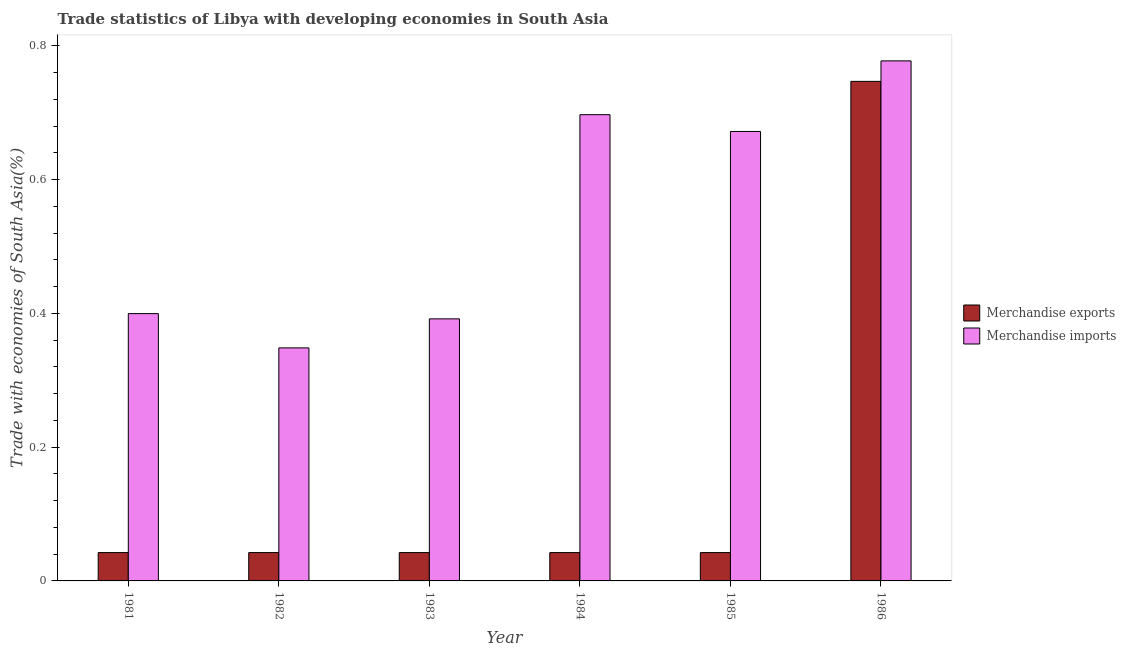How many different coloured bars are there?
Keep it short and to the point. 2. How many groups of bars are there?
Keep it short and to the point. 6. Are the number of bars per tick equal to the number of legend labels?
Your response must be concise. Yes. Are the number of bars on each tick of the X-axis equal?
Your answer should be compact. Yes. What is the label of the 6th group of bars from the left?
Offer a terse response. 1986. In how many cases, is the number of bars for a given year not equal to the number of legend labels?
Offer a very short reply. 0. What is the merchandise exports in 1985?
Make the answer very short. 0.04. Across all years, what is the maximum merchandise imports?
Keep it short and to the point. 0.78. Across all years, what is the minimum merchandise exports?
Your answer should be very brief. 0.04. In which year was the merchandise exports maximum?
Give a very brief answer. 1986. In which year was the merchandise exports minimum?
Your answer should be very brief. 1985. What is the total merchandise imports in the graph?
Your answer should be compact. 3.29. What is the difference between the merchandise exports in 1981 and that in 1986?
Offer a terse response. -0.7. What is the difference between the merchandise exports in 1986 and the merchandise imports in 1984?
Give a very brief answer. 0.7. What is the average merchandise exports per year?
Provide a succinct answer. 0.16. In how many years, is the merchandise imports greater than 0.24000000000000002 %?
Offer a terse response. 6. What is the ratio of the merchandise imports in 1984 to that in 1985?
Offer a terse response. 1.04. What is the difference between the highest and the second highest merchandise imports?
Your answer should be compact. 0.08. What is the difference between the highest and the lowest merchandise imports?
Offer a terse response. 0.43. How many years are there in the graph?
Offer a very short reply. 6. Does the graph contain grids?
Offer a very short reply. No. What is the title of the graph?
Your answer should be compact. Trade statistics of Libya with developing economies in South Asia. What is the label or title of the Y-axis?
Your answer should be very brief. Trade with economies of South Asia(%). What is the Trade with economies of South Asia(%) in Merchandise exports in 1981?
Provide a short and direct response. 0.04. What is the Trade with economies of South Asia(%) in Merchandise imports in 1981?
Provide a succinct answer. 0.4. What is the Trade with economies of South Asia(%) in Merchandise exports in 1982?
Offer a terse response. 0.04. What is the Trade with economies of South Asia(%) of Merchandise imports in 1982?
Give a very brief answer. 0.35. What is the Trade with economies of South Asia(%) in Merchandise exports in 1983?
Offer a terse response. 0.04. What is the Trade with economies of South Asia(%) in Merchandise imports in 1983?
Provide a succinct answer. 0.39. What is the Trade with economies of South Asia(%) in Merchandise exports in 1984?
Make the answer very short. 0.04. What is the Trade with economies of South Asia(%) in Merchandise imports in 1984?
Your answer should be compact. 0.7. What is the Trade with economies of South Asia(%) of Merchandise exports in 1985?
Give a very brief answer. 0.04. What is the Trade with economies of South Asia(%) of Merchandise imports in 1985?
Give a very brief answer. 0.67. What is the Trade with economies of South Asia(%) of Merchandise exports in 1986?
Provide a short and direct response. 0.75. What is the Trade with economies of South Asia(%) in Merchandise imports in 1986?
Your response must be concise. 0.78. Across all years, what is the maximum Trade with economies of South Asia(%) of Merchandise exports?
Provide a succinct answer. 0.75. Across all years, what is the maximum Trade with economies of South Asia(%) of Merchandise imports?
Your answer should be compact. 0.78. Across all years, what is the minimum Trade with economies of South Asia(%) in Merchandise exports?
Provide a succinct answer. 0.04. Across all years, what is the minimum Trade with economies of South Asia(%) in Merchandise imports?
Offer a very short reply. 0.35. What is the total Trade with economies of South Asia(%) in Merchandise exports in the graph?
Your answer should be compact. 0.96. What is the total Trade with economies of South Asia(%) in Merchandise imports in the graph?
Give a very brief answer. 3.29. What is the difference between the Trade with economies of South Asia(%) of Merchandise imports in 1981 and that in 1982?
Provide a short and direct response. 0.05. What is the difference between the Trade with economies of South Asia(%) in Merchandise exports in 1981 and that in 1983?
Offer a very short reply. -0. What is the difference between the Trade with economies of South Asia(%) in Merchandise imports in 1981 and that in 1983?
Provide a short and direct response. 0.01. What is the difference between the Trade with economies of South Asia(%) in Merchandise exports in 1981 and that in 1984?
Ensure brevity in your answer.  -0. What is the difference between the Trade with economies of South Asia(%) of Merchandise imports in 1981 and that in 1984?
Your answer should be compact. -0.3. What is the difference between the Trade with economies of South Asia(%) of Merchandise imports in 1981 and that in 1985?
Your answer should be very brief. -0.27. What is the difference between the Trade with economies of South Asia(%) in Merchandise exports in 1981 and that in 1986?
Your answer should be compact. -0.7. What is the difference between the Trade with economies of South Asia(%) of Merchandise imports in 1981 and that in 1986?
Your answer should be compact. -0.38. What is the difference between the Trade with economies of South Asia(%) of Merchandise imports in 1982 and that in 1983?
Ensure brevity in your answer.  -0.04. What is the difference between the Trade with economies of South Asia(%) in Merchandise exports in 1982 and that in 1984?
Your answer should be compact. -0. What is the difference between the Trade with economies of South Asia(%) in Merchandise imports in 1982 and that in 1984?
Make the answer very short. -0.35. What is the difference between the Trade with economies of South Asia(%) of Merchandise exports in 1982 and that in 1985?
Make the answer very short. 0. What is the difference between the Trade with economies of South Asia(%) of Merchandise imports in 1982 and that in 1985?
Provide a short and direct response. -0.32. What is the difference between the Trade with economies of South Asia(%) in Merchandise exports in 1982 and that in 1986?
Offer a very short reply. -0.7. What is the difference between the Trade with economies of South Asia(%) in Merchandise imports in 1982 and that in 1986?
Offer a very short reply. -0.43. What is the difference between the Trade with economies of South Asia(%) of Merchandise imports in 1983 and that in 1984?
Your response must be concise. -0.31. What is the difference between the Trade with economies of South Asia(%) in Merchandise imports in 1983 and that in 1985?
Keep it short and to the point. -0.28. What is the difference between the Trade with economies of South Asia(%) of Merchandise exports in 1983 and that in 1986?
Offer a very short reply. -0.7. What is the difference between the Trade with economies of South Asia(%) in Merchandise imports in 1983 and that in 1986?
Your response must be concise. -0.39. What is the difference between the Trade with economies of South Asia(%) of Merchandise imports in 1984 and that in 1985?
Give a very brief answer. 0.03. What is the difference between the Trade with economies of South Asia(%) of Merchandise exports in 1984 and that in 1986?
Offer a terse response. -0.7. What is the difference between the Trade with economies of South Asia(%) in Merchandise imports in 1984 and that in 1986?
Keep it short and to the point. -0.08. What is the difference between the Trade with economies of South Asia(%) in Merchandise exports in 1985 and that in 1986?
Make the answer very short. -0.7. What is the difference between the Trade with economies of South Asia(%) of Merchandise imports in 1985 and that in 1986?
Ensure brevity in your answer.  -0.11. What is the difference between the Trade with economies of South Asia(%) of Merchandise exports in 1981 and the Trade with economies of South Asia(%) of Merchandise imports in 1982?
Offer a terse response. -0.31. What is the difference between the Trade with economies of South Asia(%) of Merchandise exports in 1981 and the Trade with economies of South Asia(%) of Merchandise imports in 1983?
Provide a short and direct response. -0.35. What is the difference between the Trade with economies of South Asia(%) of Merchandise exports in 1981 and the Trade with economies of South Asia(%) of Merchandise imports in 1984?
Make the answer very short. -0.65. What is the difference between the Trade with economies of South Asia(%) of Merchandise exports in 1981 and the Trade with economies of South Asia(%) of Merchandise imports in 1985?
Make the answer very short. -0.63. What is the difference between the Trade with economies of South Asia(%) in Merchandise exports in 1981 and the Trade with economies of South Asia(%) in Merchandise imports in 1986?
Make the answer very short. -0.74. What is the difference between the Trade with economies of South Asia(%) in Merchandise exports in 1982 and the Trade with economies of South Asia(%) in Merchandise imports in 1983?
Provide a succinct answer. -0.35. What is the difference between the Trade with economies of South Asia(%) in Merchandise exports in 1982 and the Trade with economies of South Asia(%) in Merchandise imports in 1984?
Your response must be concise. -0.65. What is the difference between the Trade with economies of South Asia(%) in Merchandise exports in 1982 and the Trade with economies of South Asia(%) in Merchandise imports in 1985?
Provide a succinct answer. -0.63. What is the difference between the Trade with economies of South Asia(%) in Merchandise exports in 1982 and the Trade with economies of South Asia(%) in Merchandise imports in 1986?
Provide a succinct answer. -0.74. What is the difference between the Trade with economies of South Asia(%) of Merchandise exports in 1983 and the Trade with economies of South Asia(%) of Merchandise imports in 1984?
Keep it short and to the point. -0.65. What is the difference between the Trade with economies of South Asia(%) of Merchandise exports in 1983 and the Trade with economies of South Asia(%) of Merchandise imports in 1985?
Offer a very short reply. -0.63. What is the difference between the Trade with economies of South Asia(%) in Merchandise exports in 1983 and the Trade with economies of South Asia(%) in Merchandise imports in 1986?
Offer a terse response. -0.74. What is the difference between the Trade with economies of South Asia(%) of Merchandise exports in 1984 and the Trade with economies of South Asia(%) of Merchandise imports in 1985?
Offer a terse response. -0.63. What is the difference between the Trade with economies of South Asia(%) of Merchandise exports in 1984 and the Trade with economies of South Asia(%) of Merchandise imports in 1986?
Provide a short and direct response. -0.74. What is the difference between the Trade with economies of South Asia(%) in Merchandise exports in 1985 and the Trade with economies of South Asia(%) in Merchandise imports in 1986?
Your response must be concise. -0.74. What is the average Trade with economies of South Asia(%) in Merchandise exports per year?
Your response must be concise. 0.16. What is the average Trade with economies of South Asia(%) of Merchandise imports per year?
Your response must be concise. 0.55. In the year 1981, what is the difference between the Trade with economies of South Asia(%) in Merchandise exports and Trade with economies of South Asia(%) in Merchandise imports?
Your answer should be compact. -0.36. In the year 1982, what is the difference between the Trade with economies of South Asia(%) of Merchandise exports and Trade with economies of South Asia(%) of Merchandise imports?
Provide a succinct answer. -0.31. In the year 1983, what is the difference between the Trade with economies of South Asia(%) of Merchandise exports and Trade with economies of South Asia(%) of Merchandise imports?
Your response must be concise. -0.35. In the year 1984, what is the difference between the Trade with economies of South Asia(%) in Merchandise exports and Trade with economies of South Asia(%) in Merchandise imports?
Provide a short and direct response. -0.65. In the year 1985, what is the difference between the Trade with economies of South Asia(%) of Merchandise exports and Trade with economies of South Asia(%) of Merchandise imports?
Your answer should be very brief. -0.63. In the year 1986, what is the difference between the Trade with economies of South Asia(%) of Merchandise exports and Trade with economies of South Asia(%) of Merchandise imports?
Offer a terse response. -0.03. What is the ratio of the Trade with economies of South Asia(%) of Merchandise exports in 1981 to that in 1982?
Offer a terse response. 1. What is the ratio of the Trade with economies of South Asia(%) in Merchandise imports in 1981 to that in 1982?
Provide a succinct answer. 1.15. What is the ratio of the Trade with economies of South Asia(%) in Merchandise exports in 1981 to that in 1983?
Your response must be concise. 1. What is the ratio of the Trade with economies of South Asia(%) of Merchandise imports in 1981 to that in 1983?
Keep it short and to the point. 1.02. What is the ratio of the Trade with economies of South Asia(%) in Merchandise imports in 1981 to that in 1984?
Offer a very short reply. 0.57. What is the ratio of the Trade with economies of South Asia(%) of Merchandise exports in 1981 to that in 1985?
Keep it short and to the point. 1. What is the ratio of the Trade with economies of South Asia(%) of Merchandise imports in 1981 to that in 1985?
Keep it short and to the point. 0.59. What is the ratio of the Trade with economies of South Asia(%) of Merchandise exports in 1981 to that in 1986?
Provide a succinct answer. 0.06. What is the ratio of the Trade with economies of South Asia(%) in Merchandise imports in 1981 to that in 1986?
Your answer should be compact. 0.51. What is the ratio of the Trade with economies of South Asia(%) of Merchandise imports in 1982 to that in 1983?
Your answer should be very brief. 0.89. What is the ratio of the Trade with economies of South Asia(%) in Merchandise exports in 1982 to that in 1984?
Your answer should be compact. 1. What is the ratio of the Trade with economies of South Asia(%) of Merchandise imports in 1982 to that in 1984?
Keep it short and to the point. 0.5. What is the ratio of the Trade with economies of South Asia(%) of Merchandise imports in 1982 to that in 1985?
Provide a succinct answer. 0.52. What is the ratio of the Trade with economies of South Asia(%) in Merchandise exports in 1982 to that in 1986?
Ensure brevity in your answer.  0.06. What is the ratio of the Trade with economies of South Asia(%) of Merchandise imports in 1982 to that in 1986?
Keep it short and to the point. 0.45. What is the ratio of the Trade with economies of South Asia(%) of Merchandise exports in 1983 to that in 1984?
Provide a short and direct response. 1. What is the ratio of the Trade with economies of South Asia(%) of Merchandise imports in 1983 to that in 1984?
Your answer should be compact. 0.56. What is the ratio of the Trade with economies of South Asia(%) in Merchandise exports in 1983 to that in 1985?
Your answer should be compact. 1. What is the ratio of the Trade with economies of South Asia(%) in Merchandise imports in 1983 to that in 1985?
Your answer should be very brief. 0.58. What is the ratio of the Trade with economies of South Asia(%) of Merchandise exports in 1983 to that in 1986?
Ensure brevity in your answer.  0.06. What is the ratio of the Trade with economies of South Asia(%) in Merchandise imports in 1983 to that in 1986?
Your response must be concise. 0.5. What is the ratio of the Trade with economies of South Asia(%) in Merchandise exports in 1984 to that in 1985?
Offer a very short reply. 1. What is the ratio of the Trade with economies of South Asia(%) in Merchandise imports in 1984 to that in 1985?
Give a very brief answer. 1.04. What is the ratio of the Trade with economies of South Asia(%) of Merchandise exports in 1984 to that in 1986?
Give a very brief answer. 0.06. What is the ratio of the Trade with economies of South Asia(%) in Merchandise imports in 1984 to that in 1986?
Ensure brevity in your answer.  0.9. What is the ratio of the Trade with economies of South Asia(%) in Merchandise exports in 1985 to that in 1986?
Offer a terse response. 0.06. What is the ratio of the Trade with economies of South Asia(%) of Merchandise imports in 1985 to that in 1986?
Keep it short and to the point. 0.86. What is the difference between the highest and the second highest Trade with economies of South Asia(%) in Merchandise exports?
Your answer should be very brief. 0.7. What is the difference between the highest and the second highest Trade with economies of South Asia(%) in Merchandise imports?
Provide a succinct answer. 0.08. What is the difference between the highest and the lowest Trade with economies of South Asia(%) in Merchandise exports?
Keep it short and to the point. 0.7. What is the difference between the highest and the lowest Trade with economies of South Asia(%) in Merchandise imports?
Offer a very short reply. 0.43. 